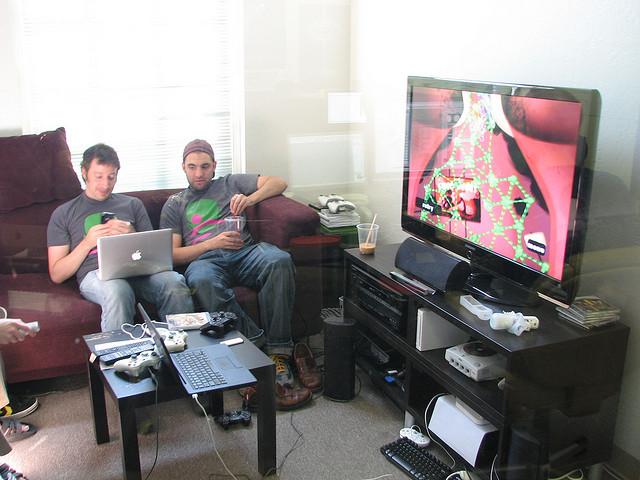How many people are wearing jeans?
Answer briefly. 2. Is the TV on?
Quick response, please. Yes. What brand is the computer?
Be succinct. Apple. 